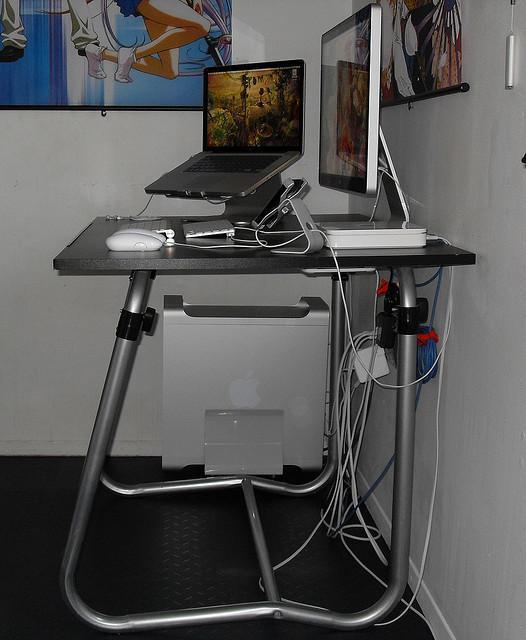How many woman are holding a donut with one hand?
Give a very brief answer. 0. 